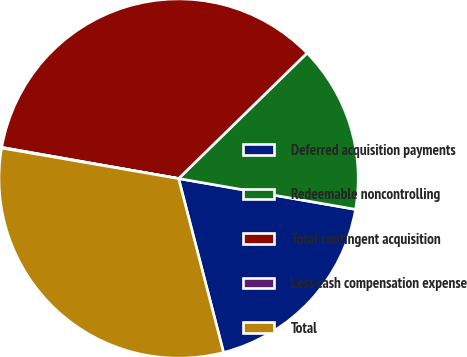Convert chart. <chart><loc_0><loc_0><loc_500><loc_500><pie_chart><fcel>Deferred acquisition payments<fcel>Redeemable noncontrolling<fcel>Total contingent acquisition<fcel>Less cash compensation expense<fcel>Total<nl><fcel>18.23%<fcel>15.06%<fcel>34.91%<fcel>0.06%<fcel>31.74%<nl></chart> 